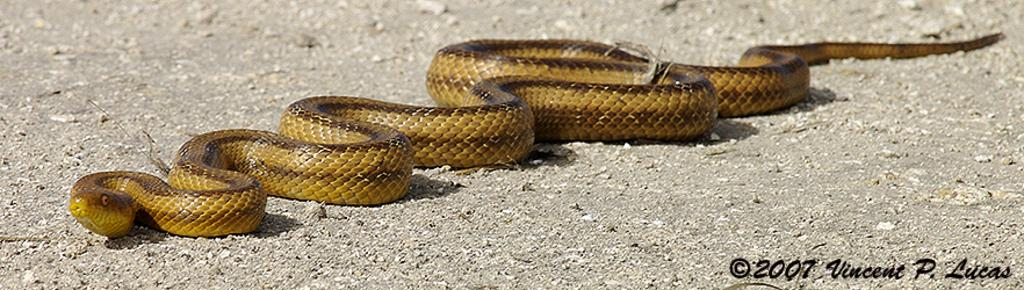What animal is represented in the image? There is a representation of a snake in the image. Where is the snake located in the image? The snake is depicted on the ground. How far away is the bell from the snake in the image? There is no bell present in the image, so it cannot be determined how far away it might be from the snake. 